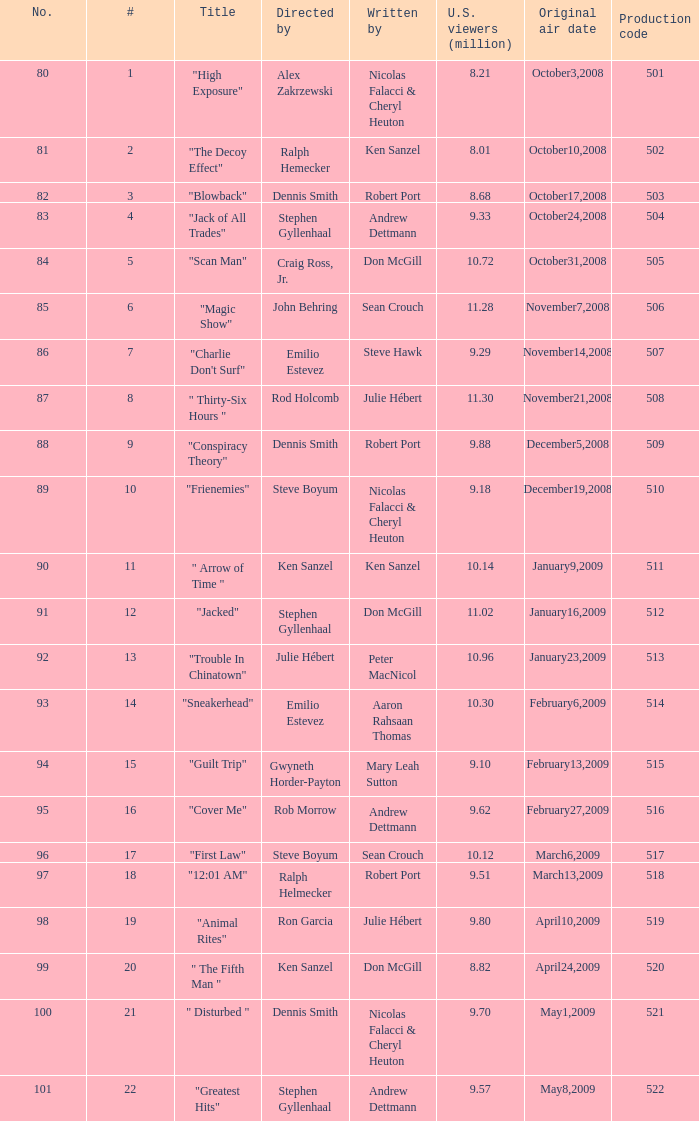For the episode attracting 9.18 million viewers in the u.s., what is its production code? 510.0. 